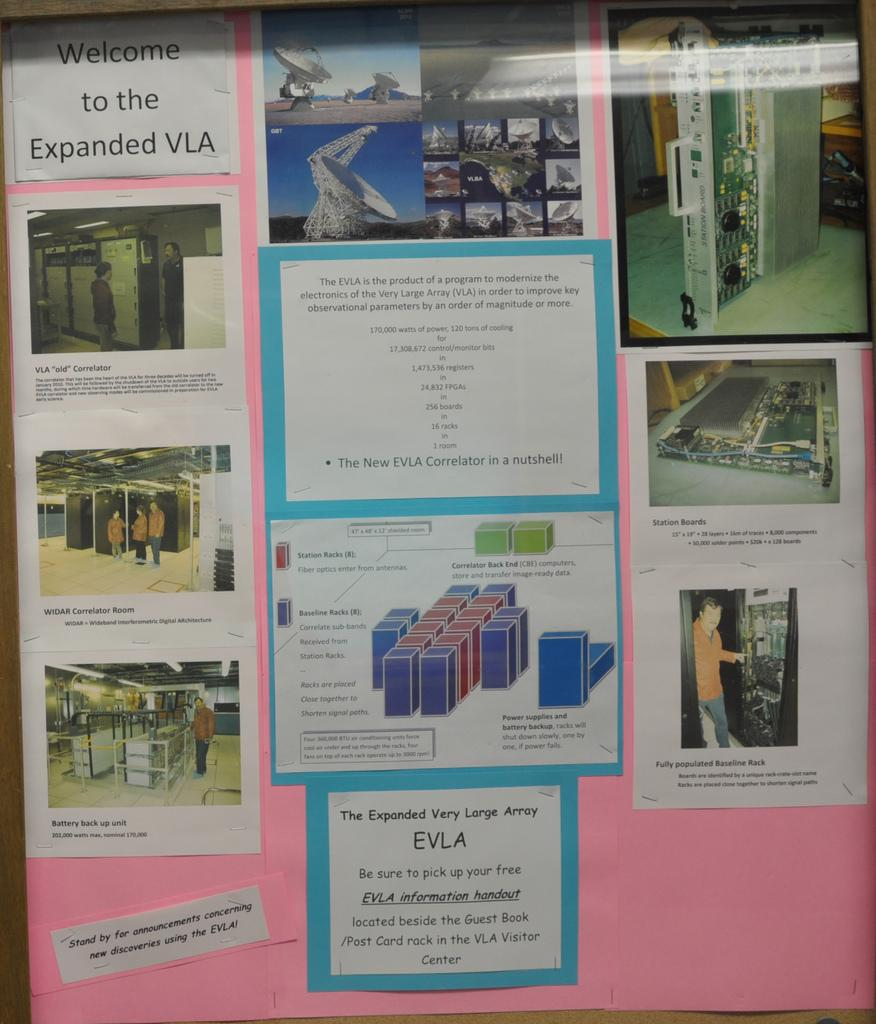<image>
Create a compact narrative representing the image presented. A pink sign says welcome to the expanded VLA. 